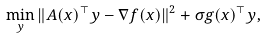Convert formula to latex. <formula><loc_0><loc_0><loc_500><loc_500>\min _ { y } \| A ( x ) ^ { \top } y - \nabla f ( x ) \| ^ { 2 } + \sigma g ( x ) ^ { \top } y ,</formula> 